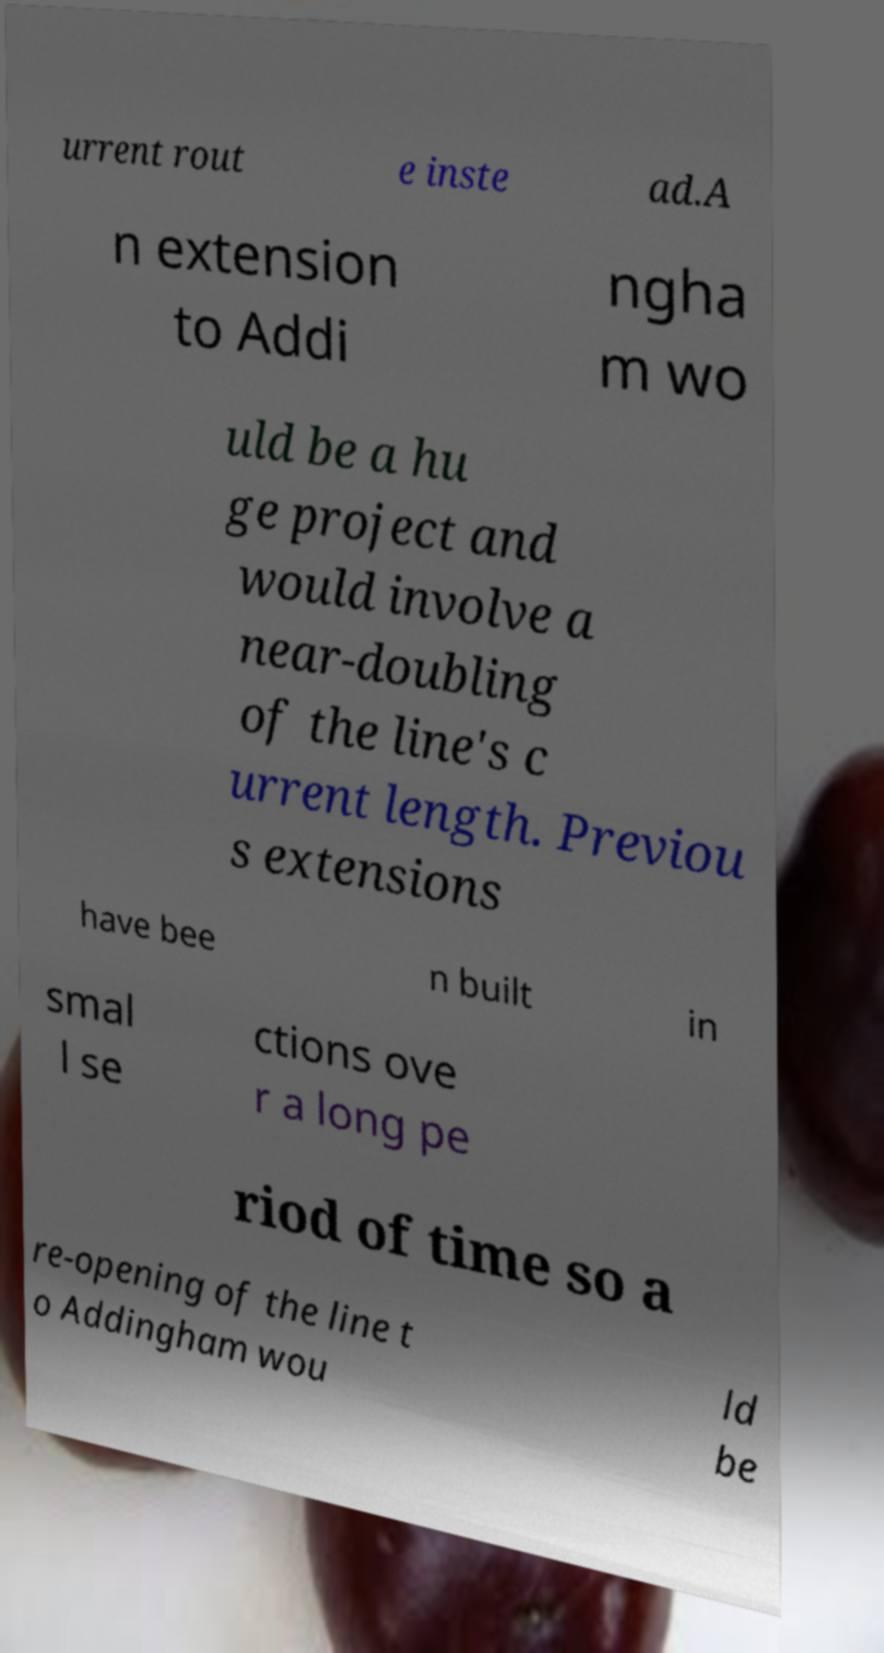Could you assist in decoding the text presented in this image and type it out clearly? urrent rout e inste ad.A n extension to Addi ngha m wo uld be a hu ge project and would involve a near-doubling of the line's c urrent length. Previou s extensions have bee n built in smal l se ctions ove r a long pe riod of time so a re-opening of the line t o Addingham wou ld be 